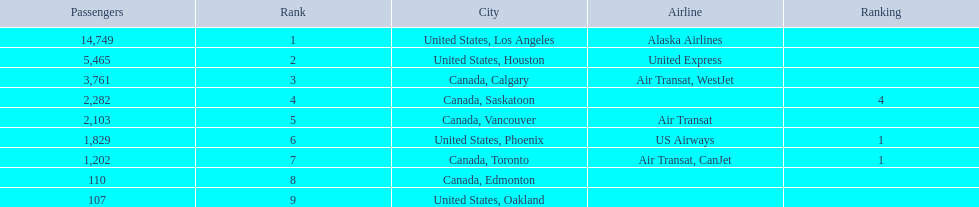What were all the passenger totals? 14,749, 5,465, 3,761, 2,282, 2,103, 1,829, 1,202, 110, 107. Which of these were to los angeles? 14,749. What other destination combined with this is closest to 19,000? Canada, Calgary. 